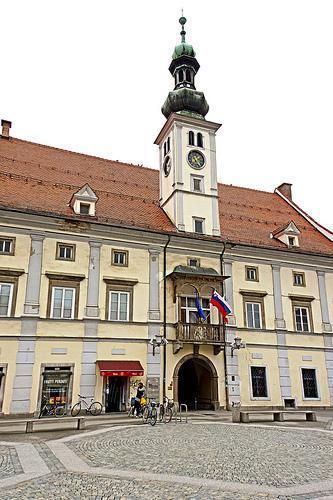How many people are shown?
Give a very brief answer. 1. How many bicycles are visible?
Give a very brief answer. 5. 